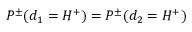<formula> <loc_0><loc_0><loc_500><loc_500>P ^ { \pm } ( d _ { 1 } = H ^ { + } ) = P ^ { \pm } ( d _ { 2 } = H ^ { + } )</formula> 